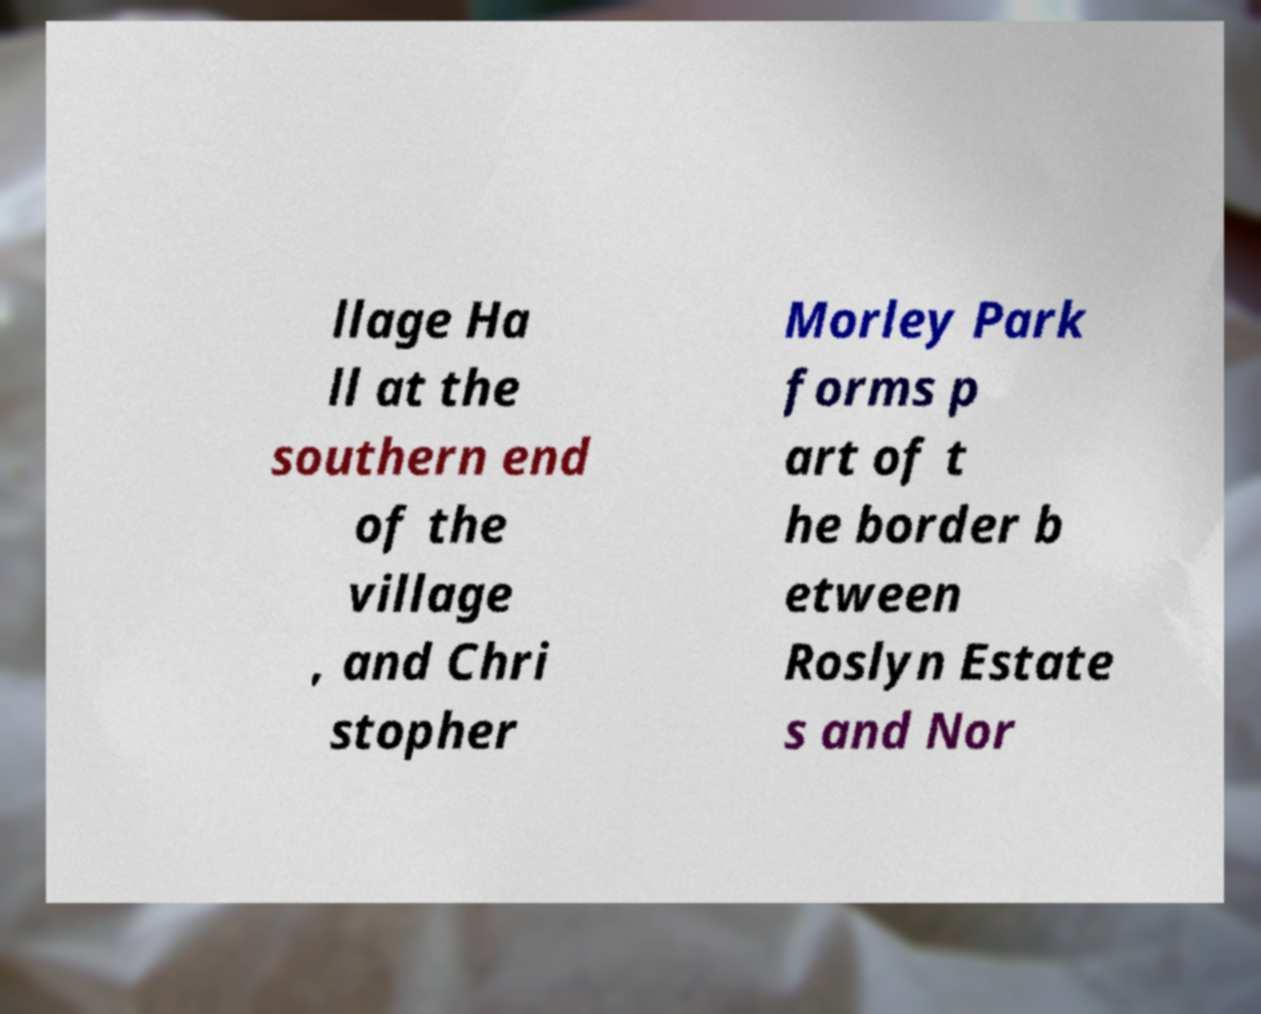Can you read and provide the text displayed in the image?This photo seems to have some interesting text. Can you extract and type it out for me? llage Ha ll at the southern end of the village , and Chri stopher Morley Park forms p art of t he border b etween Roslyn Estate s and Nor 